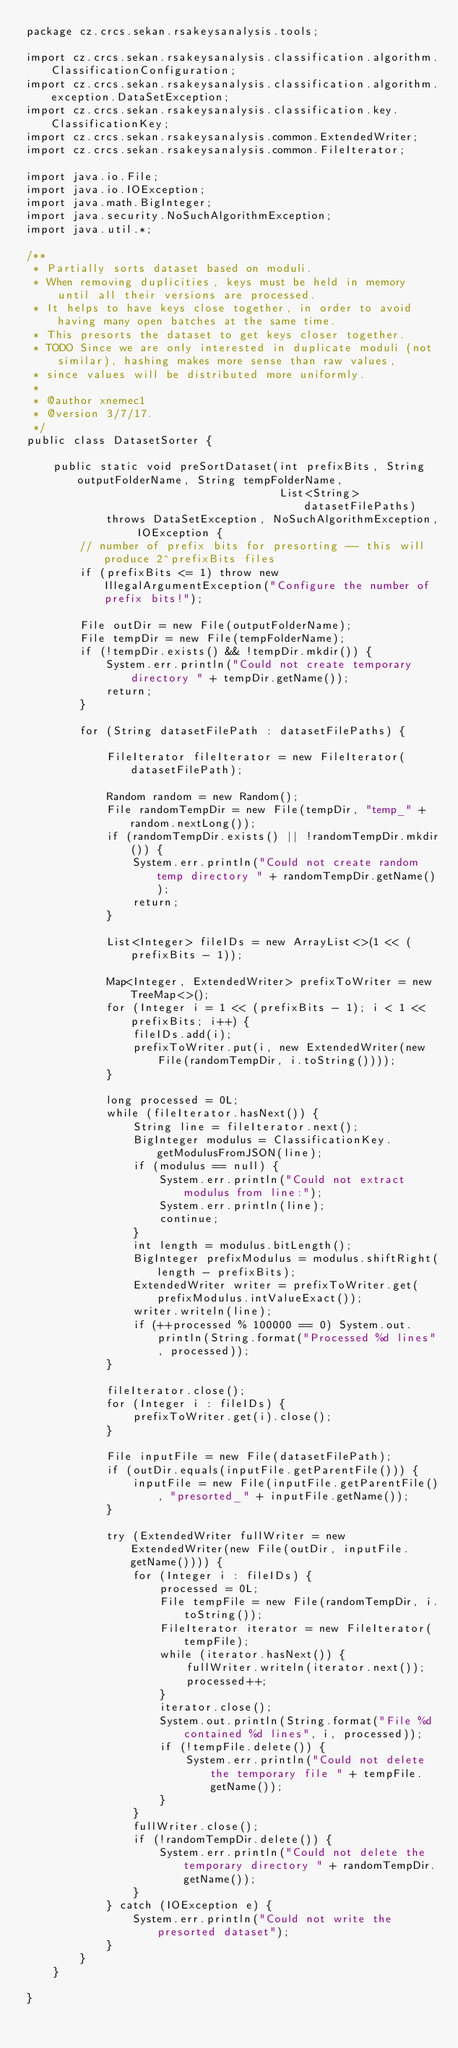<code> <loc_0><loc_0><loc_500><loc_500><_Java_>package cz.crcs.sekan.rsakeysanalysis.tools;

import cz.crcs.sekan.rsakeysanalysis.classification.algorithm.ClassificationConfiguration;
import cz.crcs.sekan.rsakeysanalysis.classification.algorithm.exception.DataSetException;
import cz.crcs.sekan.rsakeysanalysis.classification.key.ClassificationKey;
import cz.crcs.sekan.rsakeysanalysis.common.ExtendedWriter;
import cz.crcs.sekan.rsakeysanalysis.common.FileIterator;

import java.io.File;
import java.io.IOException;
import java.math.BigInteger;
import java.security.NoSuchAlgorithmException;
import java.util.*;

/**
 * Partially sorts dataset based on moduli.
 * When removing duplicities, keys must be held in memory until all their versions are processed.
 * It helps to have keys close together, in order to avoid having many open batches at the same time.
 * This presorts the dataset to get keys closer together.
 * TODO Since we are only interested in duplicate moduli (not similar), hashing makes more sense than raw values,
 * since values will be distributed more uniformly.
 *
 * @author xnemec1
 * @version 3/7/17.
 */
public class DatasetSorter {

    public static void preSortDataset(int prefixBits, String outputFolderName, String tempFolderName,
                                      List<String> datasetFilePaths)
            throws DataSetException, NoSuchAlgorithmException, IOException {
        // number of prefix bits for presorting -- this will produce 2^prefixBits files
        if (prefixBits <= 1) throw new IllegalArgumentException("Configure the number of prefix bits!");

        File outDir = new File(outputFolderName);
        File tempDir = new File(tempFolderName);
        if (!tempDir.exists() && !tempDir.mkdir()) {
            System.err.println("Could not create temporary directory " + tempDir.getName());
            return;
        }

        for (String datasetFilePath : datasetFilePaths) {

            FileIterator fileIterator = new FileIterator(datasetFilePath);

            Random random = new Random();
            File randomTempDir = new File(tempDir, "temp_" + random.nextLong());
            if (randomTempDir.exists() || !randomTempDir.mkdir()) {
                System.err.println("Could not create random temp directory " + randomTempDir.getName());
                return;
            }

            List<Integer> fileIDs = new ArrayList<>(1 << (prefixBits - 1));

            Map<Integer, ExtendedWriter> prefixToWriter = new TreeMap<>();
            for (Integer i = 1 << (prefixBits - 1); i < 1 << prefixBits; i++) {
                fileIDs.add(i);
                prefixToWriter.put(i, new ExtendedWriter(new File(randomTempDir, i.toString())));
            }

            long processed = 0L;
            while (fileIterator.hasNext()) {
                String line = fileIterator.next();
                BigInteger modulus = ClassificationKey.getModulusFromJSON(line);
                if (modulus == null) {
                    System.err.println("Could not extract modulus from line:");
                    System.err.println(line);
                    continue;
                }
                int length = modulus.bitLength();
                BigInteger prefixModulus = modulus.shiftRight(length - prefixBits);
                ExtendedWriter writer = prefixToWriter.get(prefixModulus.intValueExact());
                writer.writeln(line);
                if (++processed % 100000 == 0) System.out.println(String.format("Processed %d lines", processed));
            }

            fileIterator.close();
            for (Integer i : fileIDs) {
                prefixToWriter.get(i).close();
            }

            File inputFile = new File(datasetFilePath);
            if (outDir.equals(inputFile.getParentFile())) {
                inputFile = new File(inputFile.getParentFile(), "presorted_" + inputFile.getName());
            }

            try (ExtendedWriter fullWriter = new ExtendedWriter(new File(outDir, inputFile.getName()))) {
                for (Integer i : fileIDs) {
                    processed = 0L;
                    File tempFile = new File(randomTempDir, i.toString());
                    FileIterator iterator = new FileIterator(tempFile);
                    while (iterator.hasNext()) {
                        fullWriter.writeln(iterator.next());
                        processed++;
                    }
                    iterator.close();
                    System.out.println(String.format("File %d contained %d lines", i, processed));
                    if (!tempFile.delete()) {
                        System.err.println("Could not delete the temporary file " + tempFile.getName());
                    }
                }
                fullWriter.close();
                if (!randomTempDir.delete()) {
                    System.err.println("Could not delete the temporary directory " + randomTempDir.getName());
                }
            } catch (IOException e) {
                System.err.println("Could not write the presorted dataset");
            }
        }
    }

}
</code> 